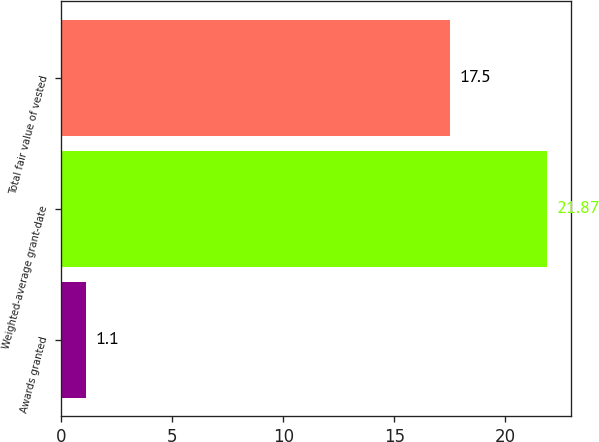<chart> <loc_0><loc_0><loc_500><loc_500><bar_chart><fcel>Awards granted<fcel>Weighted-average grant-date<fcel>Total fair value of vested<nl><fcel>1.1<fcel>21.87<fcel>17.5<nl></chart> 